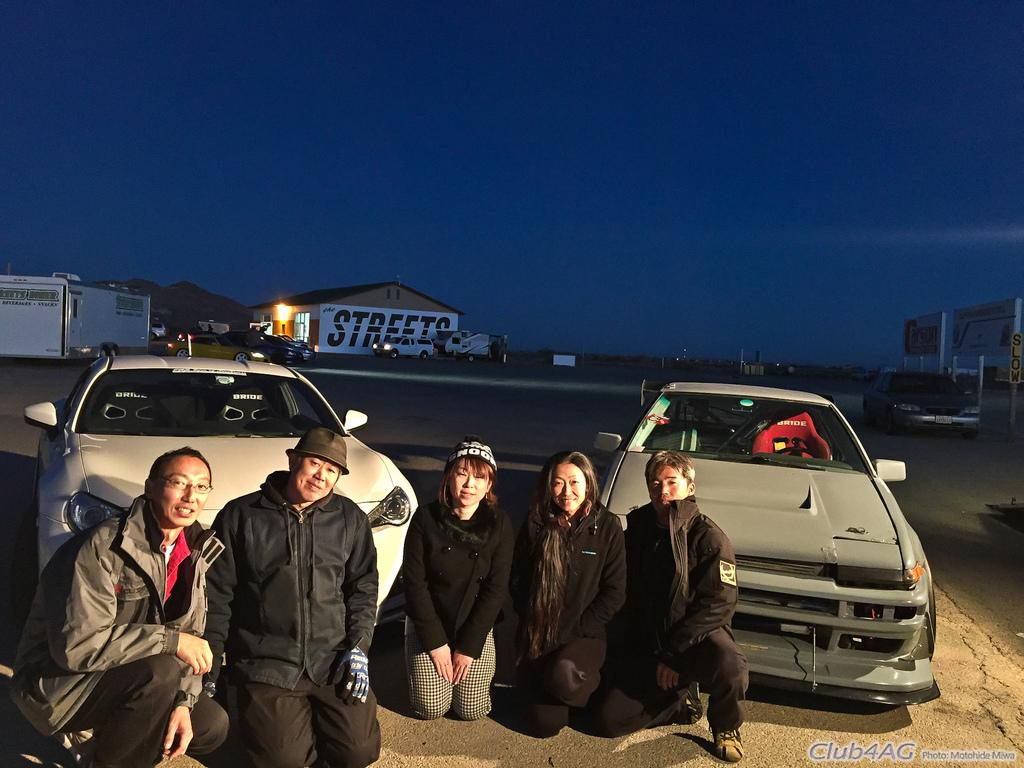How many people are in the image? There is a group of people in the image. What position are the people in? The people are in a squat position. What can be seen in the background of the image? There are two cars, buildings, and other vehicles in the background of the image. What is visible at the top of the image? The sky is visible at the top of the image. Is there a volleyball net visible in the image? There is no volleyball net present in the image. Can you see a stream running through the scene in the image? There is no stream visible in the image. 